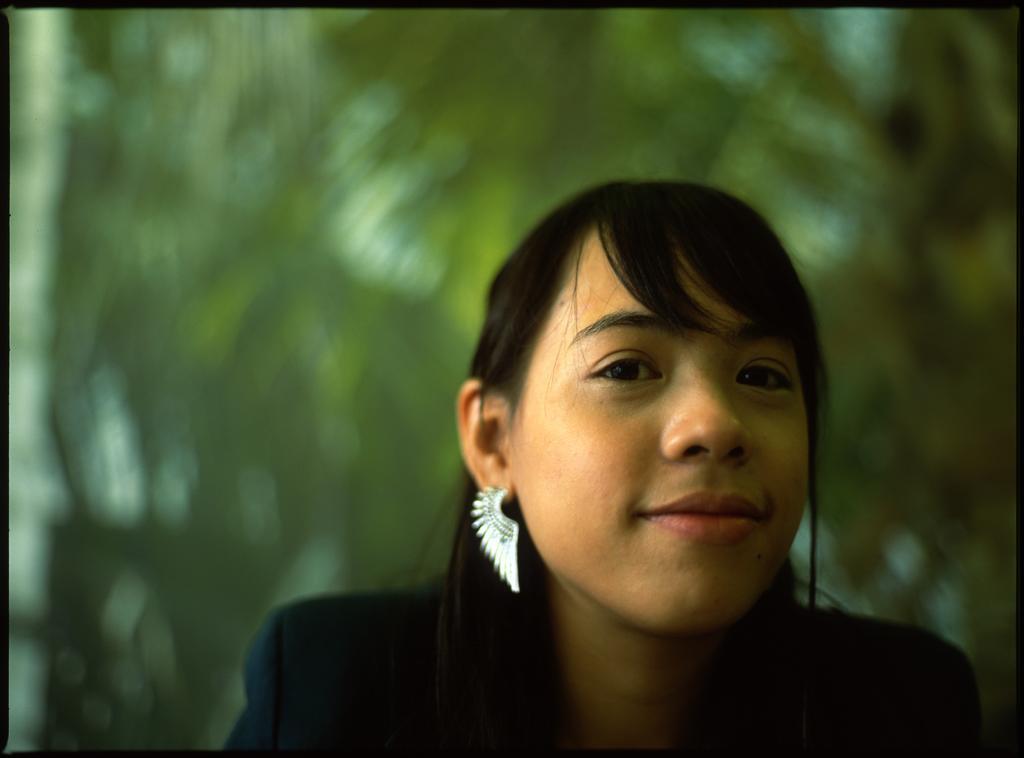In one or two sentences, can you explain what this image depicts? In the image there is a lady with earrings is smiling. Behind her there is a green color blur image. 